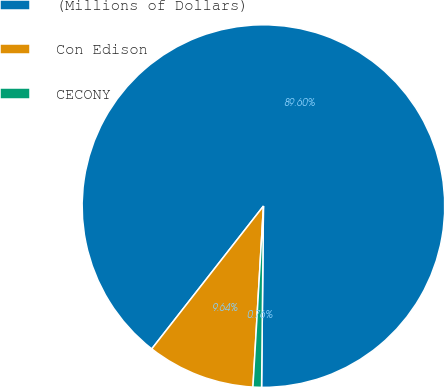Convert chart to OTSL. <chart><loc_0><loc_0><loc_500><loc_500><pie_chart><fcel>(Millions of Dollars)<fcel>Con Edison<fcel>CECONY<nl><fcel>89.6%<fcel>9.64%<fcel>0.76%<nl></chart> 